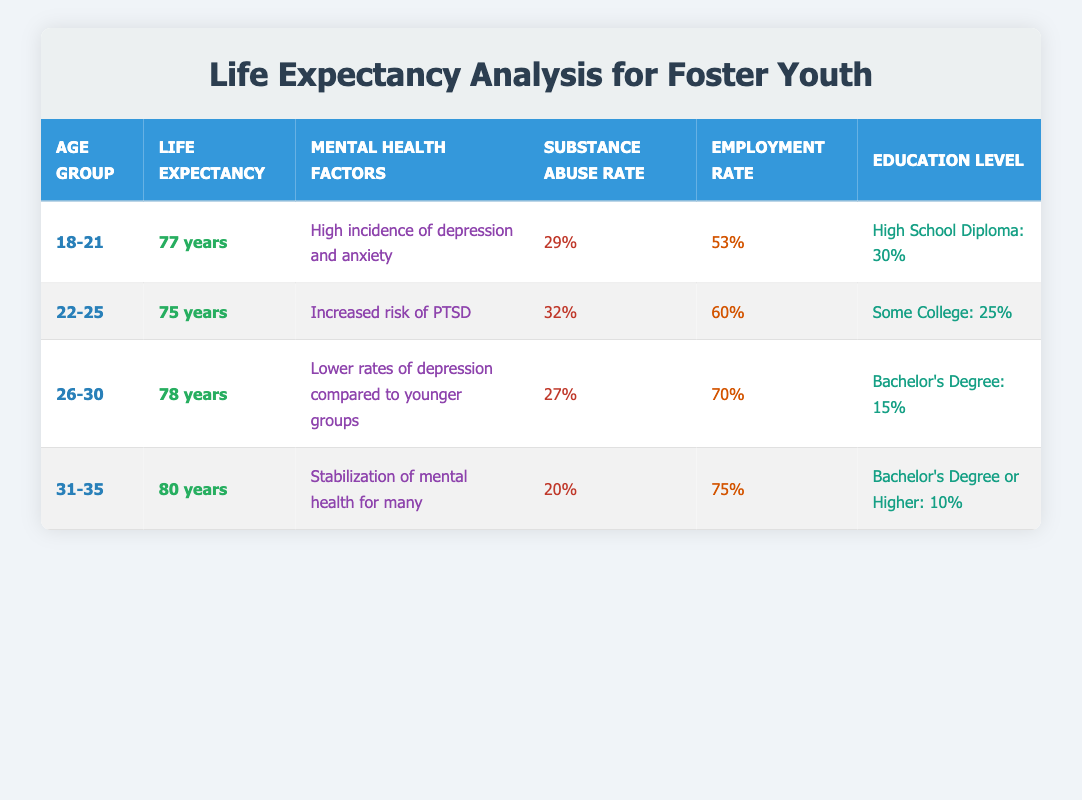What is the average life expectancy for youth aged 22-25 in foster care? The data shows that the average life expectancy for the age group 22-25 is 75 years. This is directly retrieved from the corresponding row in the table.
Answer: 75 years What percentage of youth aged 31-35 have completed a Bachelor's Degree or higher? According to the table, the education level for the age group 31-35 indicates that 10% have completed a Bachelor's Degree or higher. This percentage can be found in the relevant column for this age group.
Answer: 10% Is the substance abuse rate lower for youth aged 26-30 compared to those aged 22-25? The substance abuse rate for the age group 26-30 is 27%, while for 22-25, it is 32%. Since 27% is less than 32%, the substance abuse rate for 26-30 is indeed lower.
Answer: Yes What is the difference in average life expectancy between the age group 18-21 and 31-35? The average life expectancy for 18-21 is 77 years, and for 31-35, it is 80 years. Calculating the difference gives: 80 - 77 = 3 years. Therefore, the average life expectancy for 31-35 is 3 years longer than that for 18-21.
Answer: 3 years Do youth aged 26-30 have a higher employment rate than those aged 22-25? The employment rate for youth aged 26-30 is 70%, while for those aged 22-25, it is 60%. Since 70% is greater than 60%, it confirms that youth aged 26-30 have a higher employment rate.
Answer: Yes What is the average employment rate across all age groups? To find the average, sum the employment rates: 53 + 60 + 70 + 75 = 258. Then divide by the number of age groups (4): 258 / 4 = 64.5%. Thus, the average employment rate is 64.5%.
Answer: 64.5% Is there a correlation between age group and average life expectancy in the data? The average life expectancy seems to increase with age: 77 years (18-21), 75 years (22-25), 78 years (26-30), and 80 years (31-35). This trend suggests a positive correlation between age and life expectancy based on the data provided.
Answer: Yes What is the mental health factor reported for youth aged 22-25? The mental health factor for the age group 22-25 is listed as "Increased risk of PTSD." This information is directly taken from the table.
Answer: Increased risk of PTSD 